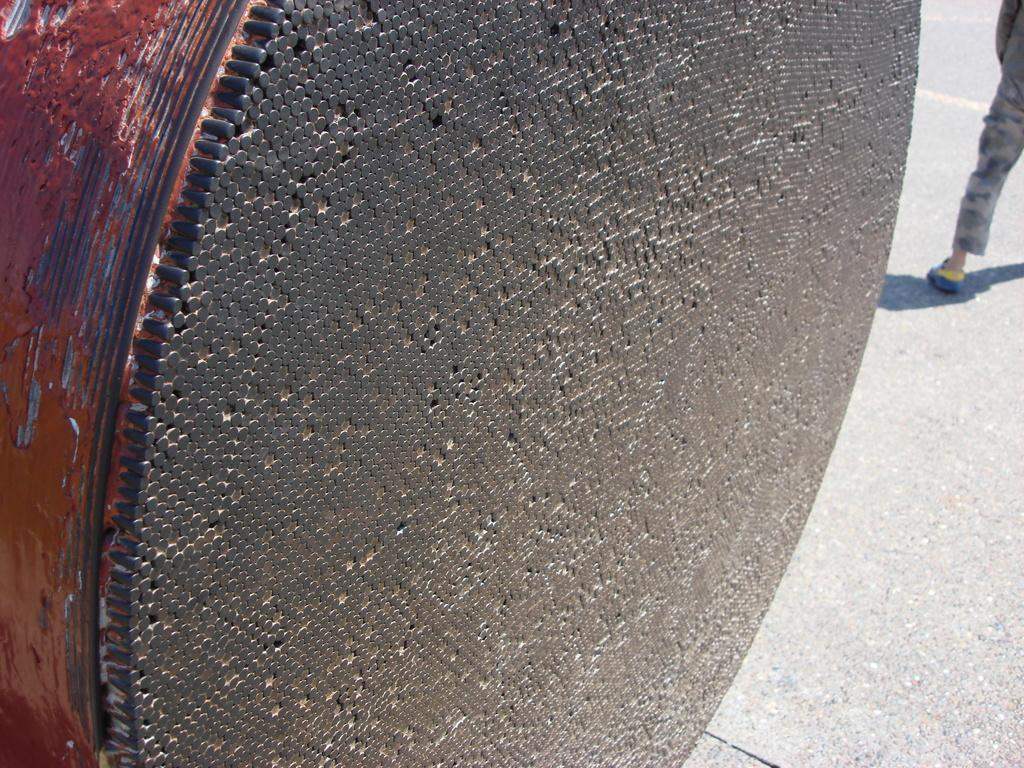What is the main subject of the image? The main subject of the image is a bundle of cable tied together. Can you describe the condition of the cable? The cable is tied together in the image. Is there any other object or person visible in the image? Yes, there is a person's leg visible on the road in the image. What type of chicken can be seen crossing the road in the image? There is no chicken present in the image, and therefore no such activity can be observed. 